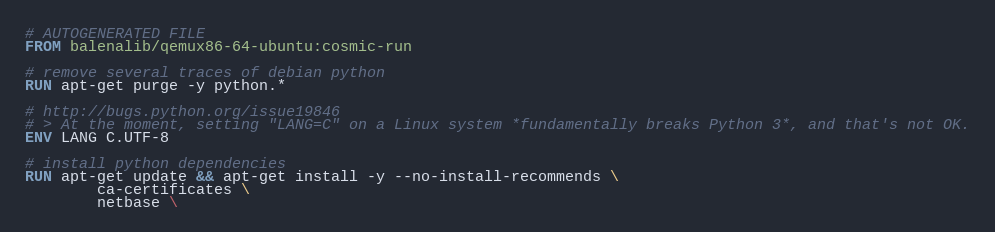<code> <loc_0><loc_0><loc_500><loc_500><_Dockerfile_># AUTOGENERATED FILE
FROM balenalib/qemux86-64-ubuntu:cosmic-run

# remove several traces of debian python
RUN apt-get purge -y python.*

# http://bugs.python.org/issue19846
# > At the moment, setting "LANG=C" on a Linux system *fundamentally breaks Python 3*, and that's not OK.
ENV LANG C.UTF-8

# install python dependencies
RUN apt-get update && apt-get install -y --no-install-recommends \
		ca-certificates \
		netbase \</code> 